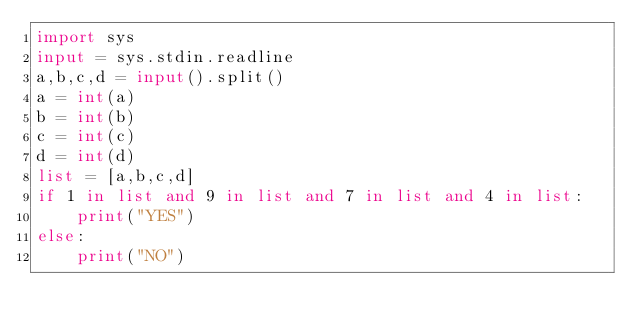<code> <loc_0><loc_0><loc_500><loc_500><_Python_>import sys
input = sys.stdin.readline
a,b,c,d = input().split()
a = int(a)
b = int(b)
c = int(c)
d = int(d)
list = [a,b,c,d]
if 1 in list and 9 in list and 7 in list and 4 in list:
    print("YES")
else:
    print("NO")</code> 